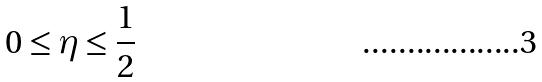Convert formula to latex. <formula><loc_0><loc_0><loc_500><loc_500>0 \leq \eta \leq \frac { 1 } { 2 }</formula> 